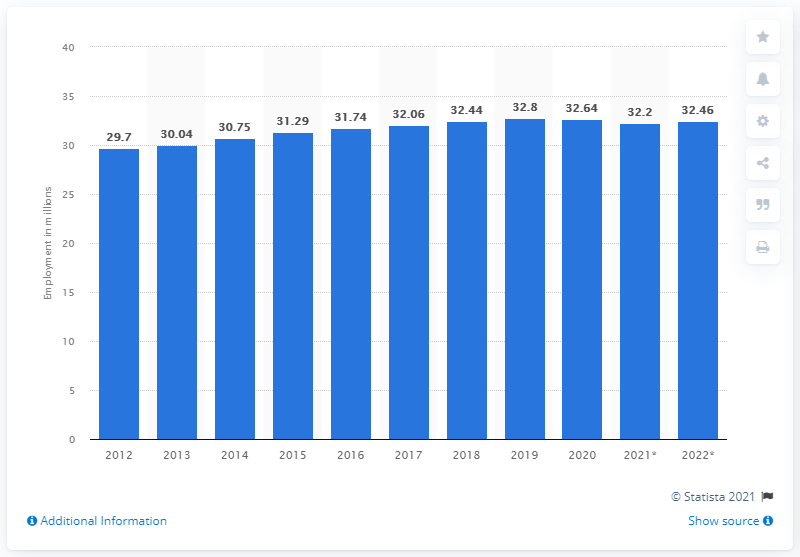Point out several critical features in this image. The employment in the United Kingdom ended in 2020. The employment in the United Kingdom ended in 2020. In 2020, the UK employed 32.46 people. 